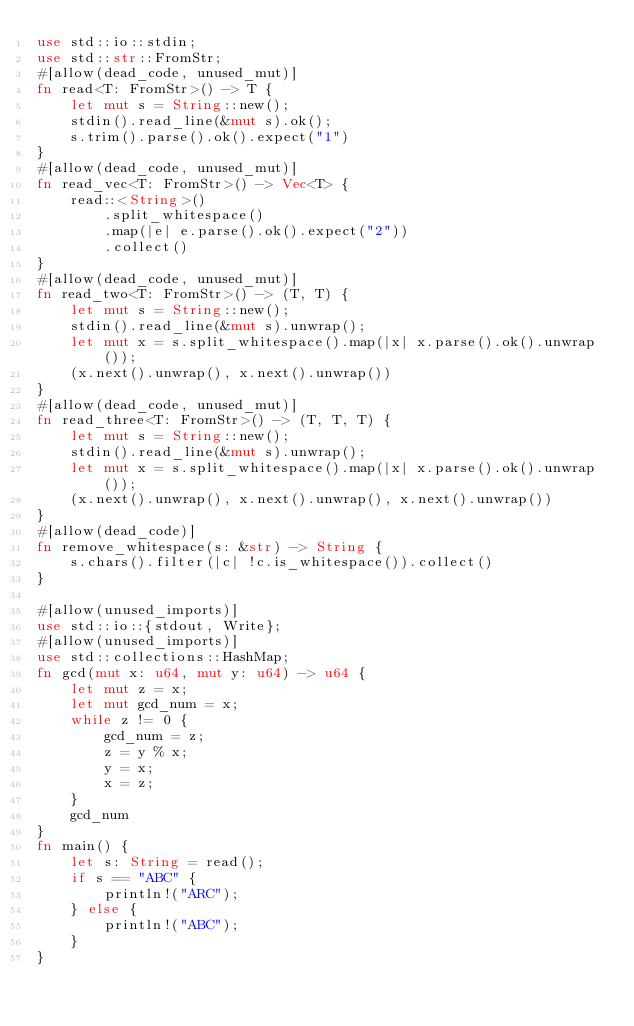<code> <loc_0><loc_0><loc_500><loc_500><_Rust_>use std::io::stdin;
use std::str::FromStr;
#[allow(dead_code, unused_mut)]
fn read<T: FromStr>() -> T {
    let mut s = String::new();
    stdin().read_line(&mut s).ok();
    s.trim().parse().ok().expect("1")
}
#[allow(dead_code, unused_mut)]
fn read_vec<T: FromStr>() -> Vec<T> {
    read::<String>()
        .split_whitespace()
        .map(|e| e.parse().ok().expect("2"))
        .collect()
}
#[allow(dead_code, unused_mut)]
fn read_two<T: FromStr>() -> (T, T) {
    let mut s = String::new();
    stdin().read_line(&mut s).unwrap();
    let mut x = s.split_whitespace().map(|x| x.parse().ok().unwrap());
    (x.next().unwrap(), x.next().unwrap())
}
#[allow(dead_code, unused_mut)]
fn read_three<T: FromStr>() -> (T, T, T) {
    let mut s = String::new();
    stdin().read_line(&mut s).unwrap();
    let mut x = s.split_whitespace().map(|x| x.parse().ok().unwrap());
    (x.next().unwrap(), x.next().unwrap(), x.next().unwrap())
}
#[allow(dead_code)]
fn remove_whitespace(s: &str) -> String {
    s.chars().filter(|c| !c.is_whitespace()).collect()
}

#[allow(unused_imports)]
use std::io::{stdout, Write};
#[allow(unused_imports)]
use std::collections::HashMap;
fn gcd(mut x: u64, mut y: u64) -> u64 {
    let mut z = x;
    let mut gcd_num = x;
    while z != 0 {
        gcd_num = z;
        z = y % x;
        y = x;
        x = z;
    }
    gcd_num
}
fn main() {
    let s: String = read();
    if s == "ABC" {
        println!("ARC");
    } else {
        println!("ABC");
    }
}
</code> 